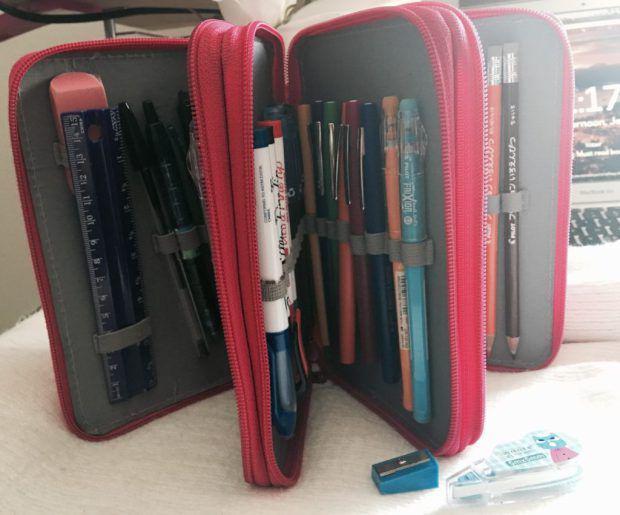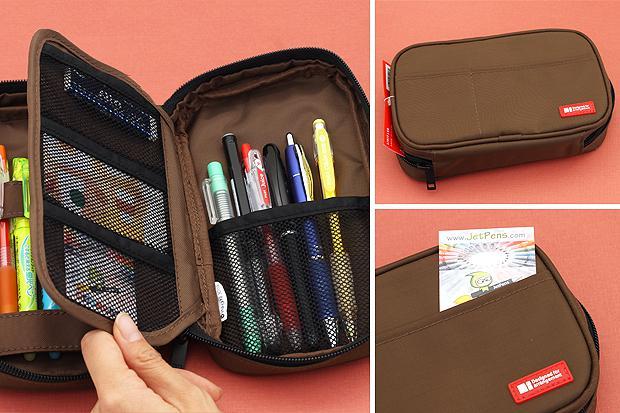The first image is the image on the left, the second image is the image on the right. Evaluate the accuracy of this statement regarding the images: "A hand is opening a pencil case in the right image.". Is it true? Answer yes or no. Yes. 